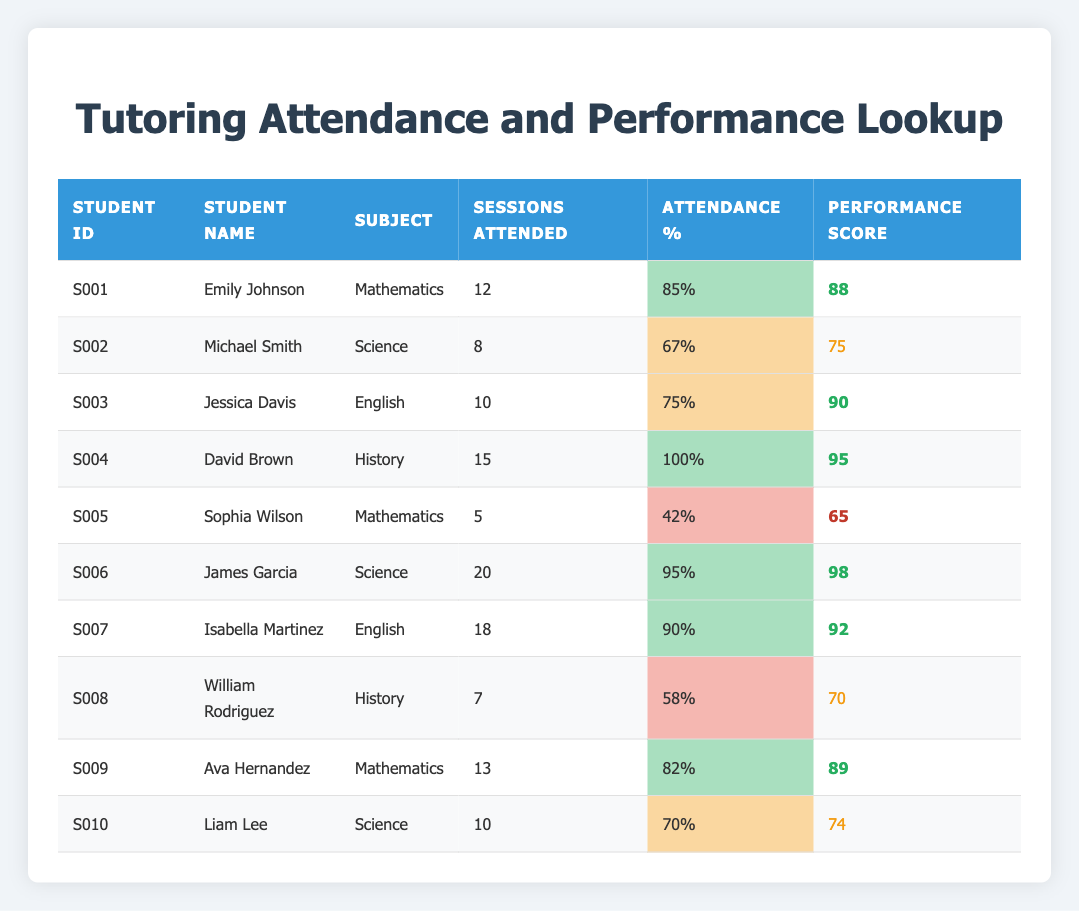What is the academic performance score of David Brown? David Brown's academic performance score is listed in the table under the Performance Score column for his row. The score is noted as 95.
Answer: 95 How many tutoring sessions did Michael Smith attend? The table indicates that Michael Smith attended 8 tutoring sessions, which can be found directly in his row under the Sessions Attended column.
Answer: 8 Which student has the highest attendance percentage? By comparing the attendance percentages in the table from the Attendance % column, David Brown has the highest attendance percentage at 100%.
Answer: 100% What is the average academic performance score of students who attended 10 or more sessions? The scores of students who attended 10 or more sessions are 88, 90, 95, 98, 92, and 89. Summing these gives 88 + 90 + 95 + 98 + 92 + 89 = 552. There are 6 students, so the average is 552 / 6 = 92.
Answer: 92 Is Ava Hernandez's attendance percentage above 80%? In the table, Ava Hernandez's attendance percentage is given as 82%, which is above 80%. Therefore, the answer is yes.
Answer: Yes Who scored below 70 and how many sessions did they attend? Sophia Wilson is the only student who scored below 70, with a score of 65. In the table, her sessions attended are noted as 5.
Answer: Sophia Wilson, 5 sessions What is the difference in performance score between the students with the highest and lowest attendance percentages? The highest attendance percentage is 100% (David Brown with 95 score) and the lowest is 42% (Sophia Wilson with 65 score). The difference in performance scores is 95 - 65 = 30.
Answer: 30 Are there more students with a performance score above 85 than those below 75? Examining the performance scores, Emily Johnson, Jessica Davis, David Brown, James Garcia, Isabella Martinez, and Ava Hernandez scored above 85 (total of 6 students), while only Michael Smith and Liam Lee scored below 75 (total of 2 students). Since 6 is greater than 2, the answer is yes.
Answer: Yes How many students attended less than 10 tutoring sessions? Checking the Sessions Attended column, the students who attended less than 10 sessions are Michael Smith (8), Sophia Wilson (5), William Rodriguez (7), and Liam Lee (10, which does not count). Thus, there are 3 students who attended less than 10 sessions.
Answer: 3 